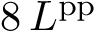<formula> <loc_0><loc_0><loc_500><loc_500>8 \, L ^ { p p }</formula> 